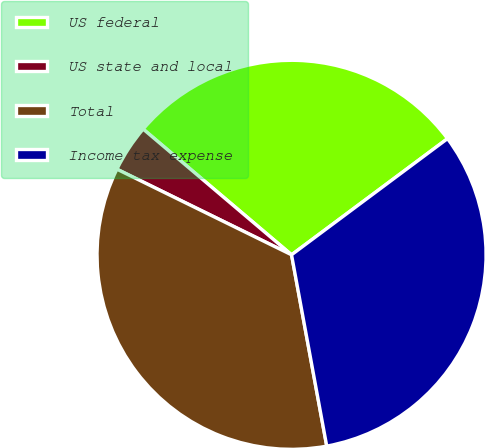Convert chart to OTSL. <chart><loc_0><loc_0><loc_500><loc_500><pie_chart><fcel>US federal<fcel>US state and local<fcel>Total<fcel>Income tax expense<nl><fcel>28.62%<fcel>3.93%<fcel>35.15%<fcel>32.29%<nl></chart> 